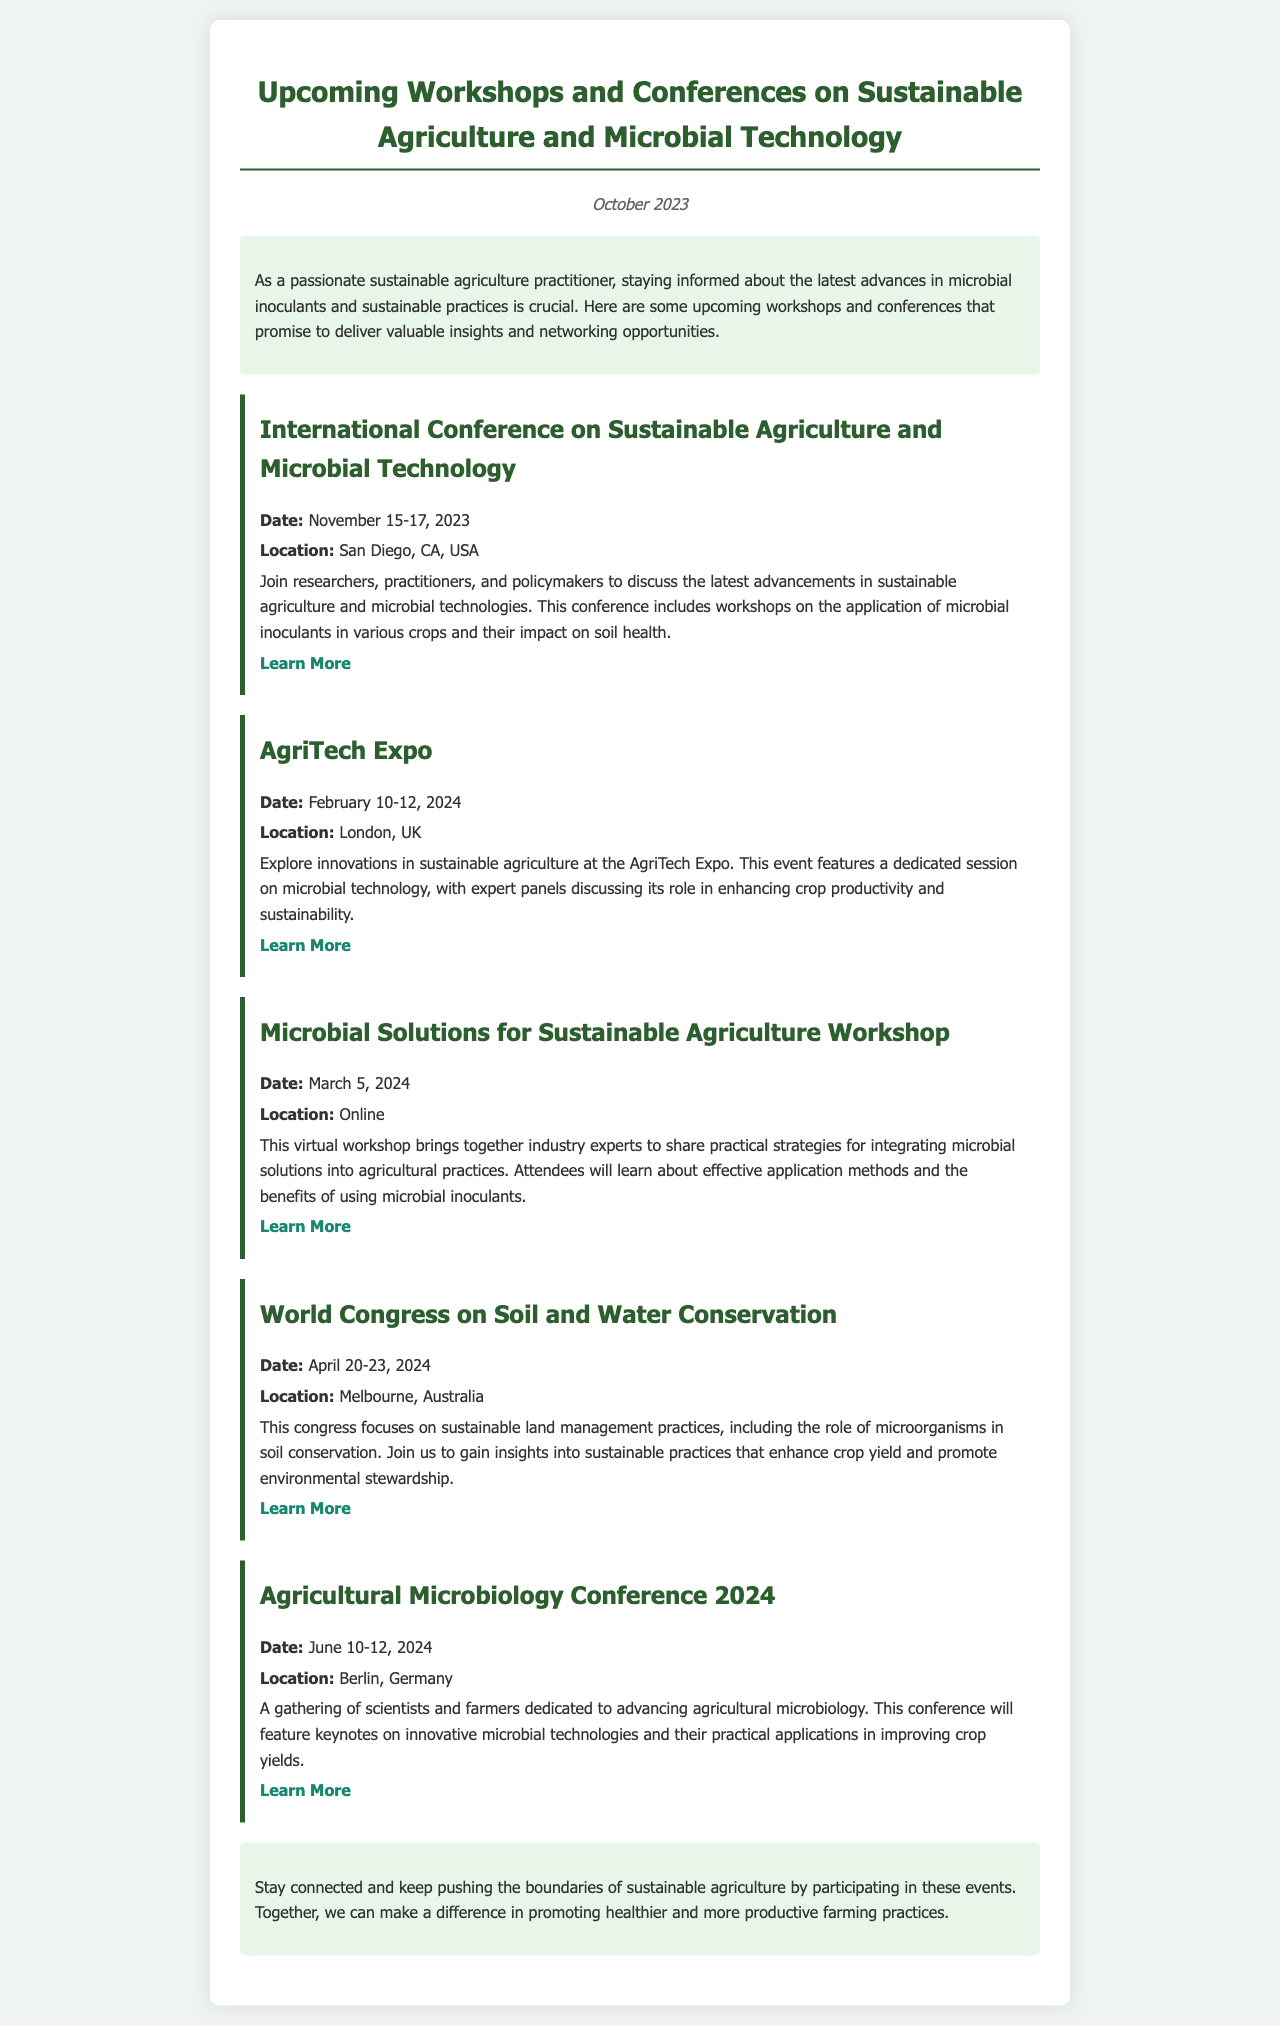What is the date of the International Conference on Sustainable Agriculture and Microbial Technology? The date is explicitly mentioned in the document as November 15-17, 2023.
Answer: November 15-17, 2023 Where is the AgriTech Expo being held? The location for the AgriTech Expo is clearly stated as London, UK.
Answer: London, UK What specific focus will the workshop on March 5, 2024, have? The document describes the workshop as focusing on practical strategies for integrating microbial solutions into agricultural practices.
Answer: Integrating microbial solutions What are the dates for the Agricultural Microbiology Conference 2024? The specific dates for this conference are provided as June 10-12, 2024.
Answer: June 10-12, 2024 Which event includes discussions on the application of microbial inoculants in various crops? The International Conference on Sustainable Agriculture and Microbial Technology includes these discussions as noted in the event description.
Answer: International Conference on Sustainable Agriculture and Microbial Technology What is the primary theme of the World Congress on Soil and Water Conservation? The document mentions the focus on sustainable land management practices and the role of microorganisms in soil conservation.
Answer: Sustainable land management practices What type of event is the Microbial Solutions for Sustainable Agriculture Workshop? The document clearly states that this is a virtual workshop.
Answer: Virtual workshop What is the website for learning more about the Agricultural Microbiology Conference 2024? The document provides a direct link to the conference's website for additional information.
Answer: www.agriculturalmicrobiology2024.com 